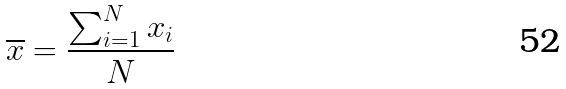<formula> <loc_0><loc_0><loc_500><loc_500>\overline { x } = \frac { \sum _ { i = 1 } ^ { N } x _ { i } } { N }</formula> 